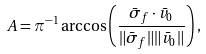<formula> <loc_0><loc_0><loc_500><loc_500>A = \pi ^ { - 1 } \arccos \left ( \frac { \bar { \sigma } _ { f } \cdot \bar { v } _ { 0 } } { \| \bar { \sigma } _ { f } \| \| \bar { v } _ { 0 } \| } \right ) ,</formula> 